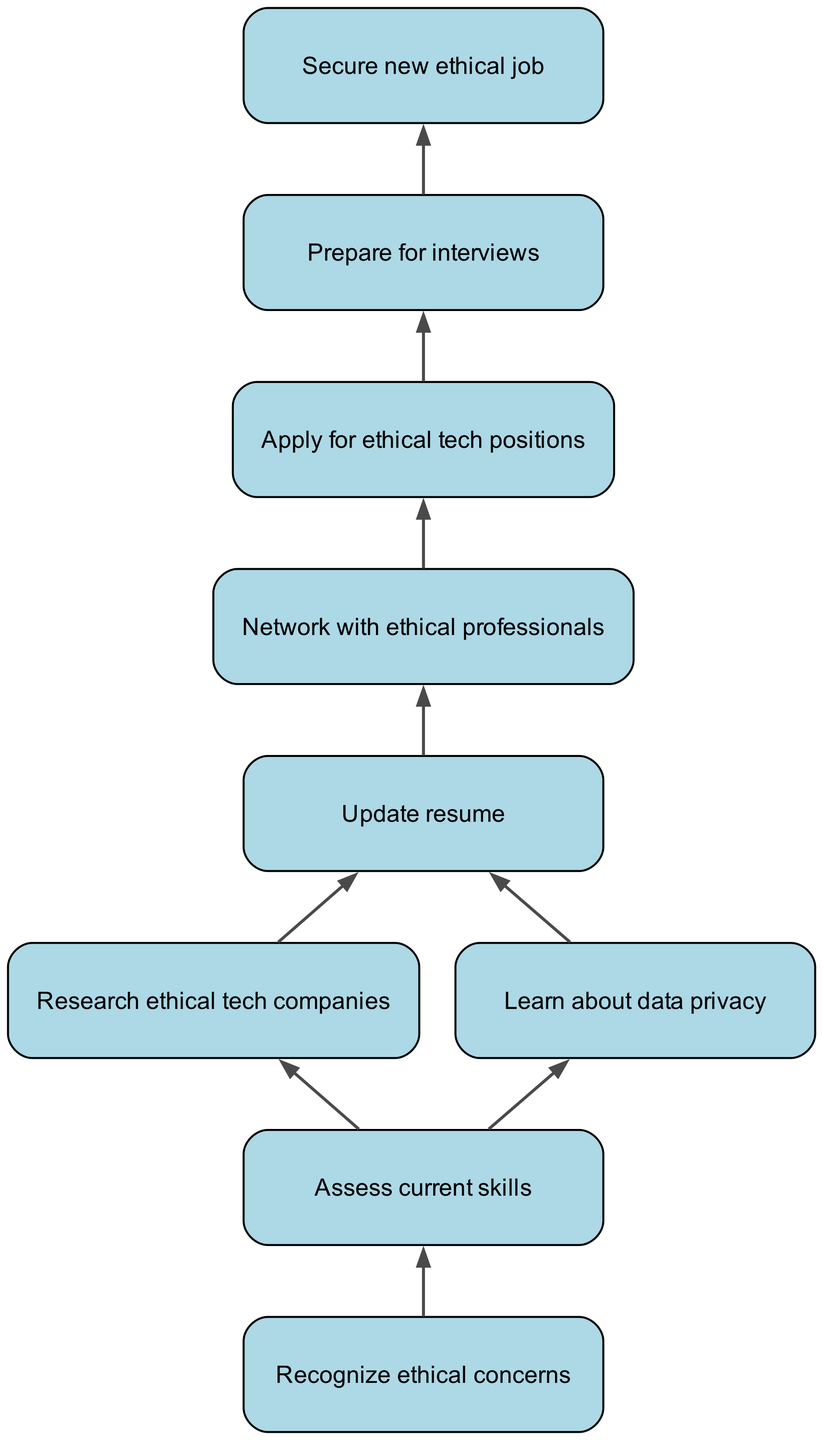What is the first step in the career transition roadmap? The first node in the diagram is labeled "Recognize ethical concerns," indicating that this is the starting point of the flowchart.
Answer: Recognize ethical concerns How many nodes are present in the diagram? By counting the nodes listed in the data structure, there are a total of nine distinct nodes in the diagram.
Answer: 9 What is the last step in the career transition process? The final node in the flowchart is "Secure new ethical job," which indicates the endpoint of the process.
Answer: Secure new ethical job Which step comes after "Update resume"? The edge following "Update resume" points to "Network with ethical professionals," meaning this is the next action to take in the workflow.
Answer: Network with ethical professionals Is there a step that involves learning about data privacy? Yes, the node labeled "Learn about data privacy" is included in the diagram, indicating that this is a necessary part of the transition process.
Answer: Learn about data privacy What are the two actions you can take after assessing your current skills? The flowchart shows that after assessing current skills, the next actions involve either researching ethical tech companies or learning about data privacy.
Answer: Research ethical tech companies or learn about data privacy How does the process of applying for ethical tech positions relate to networking? "Apply for ethical tech positions" follows "Network with ethical professionals" in the diagram, indicating that networking is a precursor to applying for jobs, which implies its importance in the job acquisition process.
Answer: Networking precedes applying for positions What is the relationship between "Prepare for interviews" and "Secure new ethical job"? "Prepare for interviews" is directly connected to "Secure new ethical job" via an edge, signifying that successfully preparing for interviews is a crucial step towards obtaining a job.
Answer: Prepare for interviews leads to securing a job What is the purpose of assessing current skills in this roadmap? Assessing current skills is a foundational step that helps individuals identify their capabilities before moving towards researching companies or learning new concepts, setting the stage for targeted improvements.
Answer: Identify capabilities before proceeding 